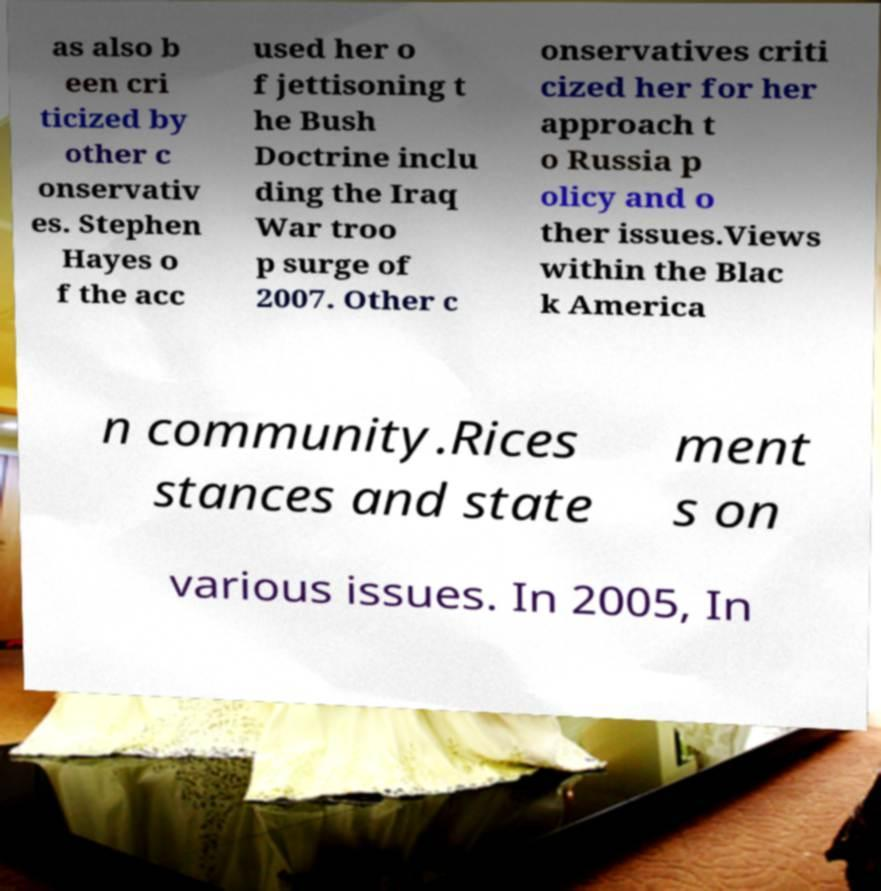I need the written content from this picture converted into text. Can you do that? as also b een cri ticized by other c onservativ es. Stephen Hayes o f the acc used her o f jettisoning t he Bush Doctrine inclu ding the Iraq War troo p surge of 2007. Other c onservatives criti cized her for her approach t o Russia p olicy and o ther issues.Views within the Blac k America n community.Rices stances and state ment s on various issues. In 2005, In 